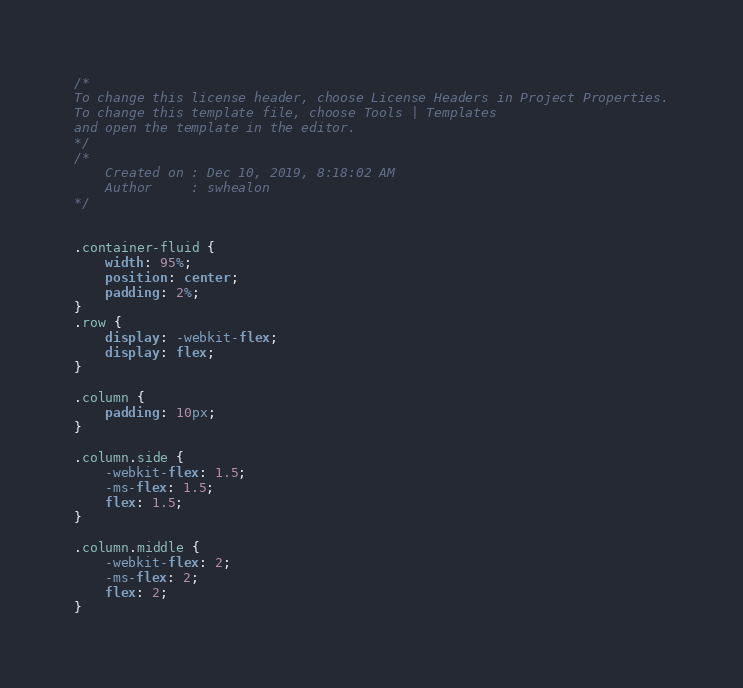<code> <loc_0><loc_0><loc_500><loc_500><_CSS_>/*
To change this license header, choose License Headers in Project Properties.
To change this template file, choose Tools | Templates
and open the template in the editor.
*/
/* 
    Created on : Dec 10, 2019, 8:18:02 AM
    Author     : swhealon
*/


.container-fluid {
    width: 95%;
    position: center;
    padding: 2%;
}
.row {
    display: -webkit-flex;
    display: flex;
}

.column {
    padding: 10px;
}

.column.side {
    -webkit-flex: 1.5;
    -ms-flex: 1.5;
    flex: 1.5;
}

.column.middle {
    -webkit-flex: 2;
    -ms-flex: 2;
    flex: 2;
}

</code> 